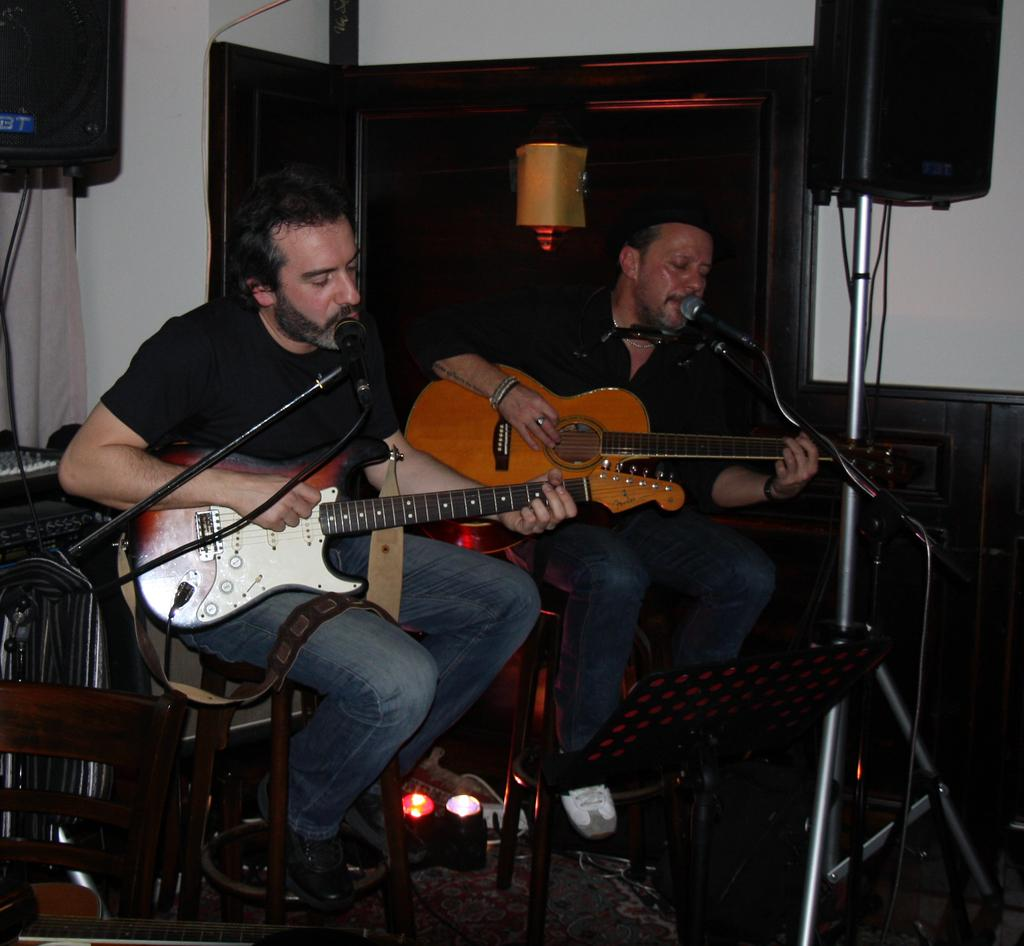How many people are in the image? There are two men in the image. What are the men holding in the image? Both men are holding guitars. Where are the men positioned in the image? Both men are sitting in front of a microphone. What can be seen in the background of the image? There is equipment, a wall, and a light visible in the background. Can you see a cat playing with a ball of glue in the image? No, there is no cat or glue present in the image. 